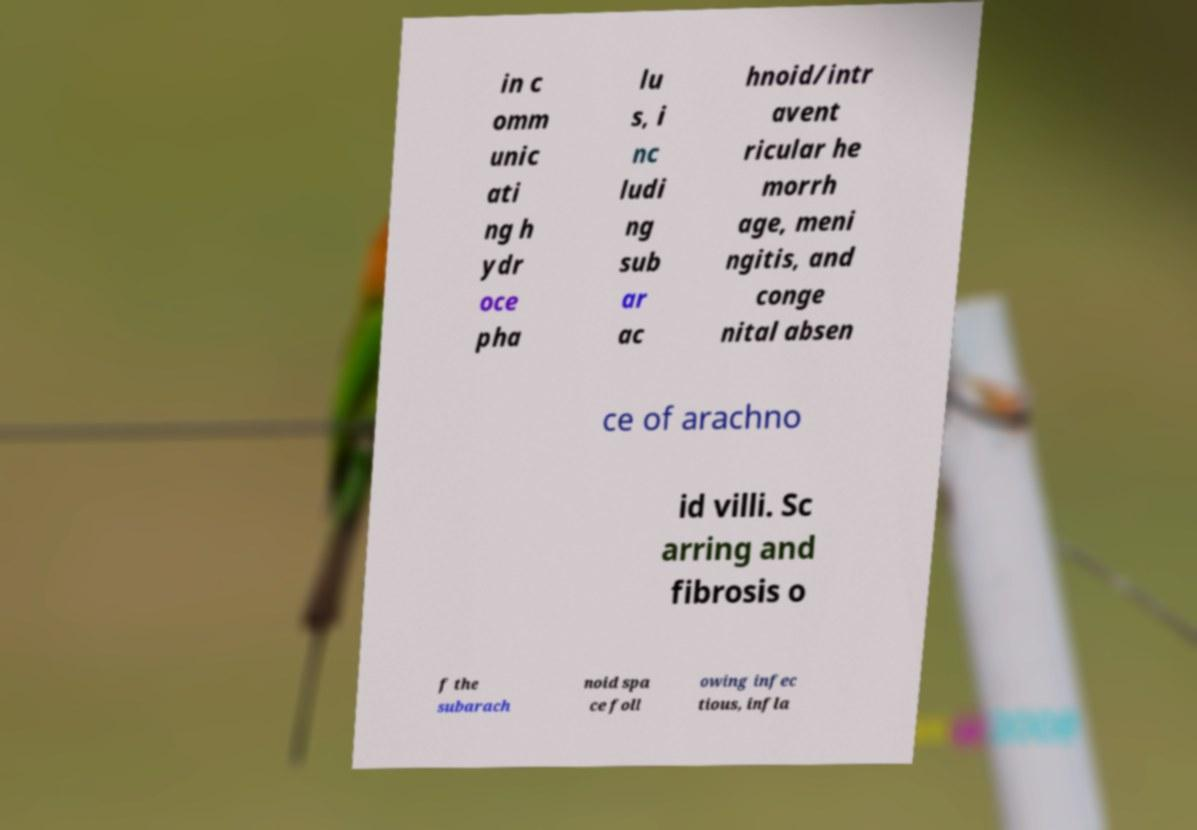Please read and relay the text visible in this image. What does it say? in c omm unic ati ng h ydr oce pha lu s, i nc ludi ng sub ar ac hnoid/intr avent ricular he morrh age, meni ngitis, and conge nital absen ce of arachno id villi. Sc arring and fibrosis o f the subarach noid spa ce foll owing infec tious, infla 